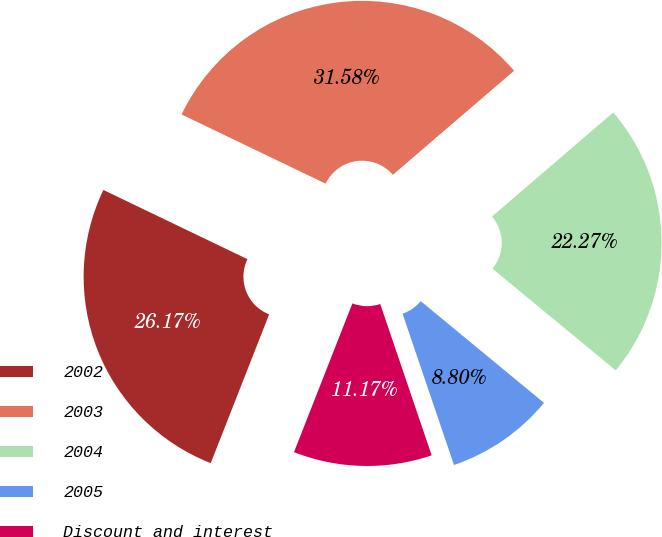Convert chart. <chart><loc_0><loc_0><loc_500><loc_500><pie_chart><fcel>2002<fcel>2003<fcel>2004<fcel>2005<fcel>Discount and interest<nl><fcel>26.17%<fcel>31.58%<fcel>22.27%<fcel>8.8%<fcel>11.17%<nl></chart> 